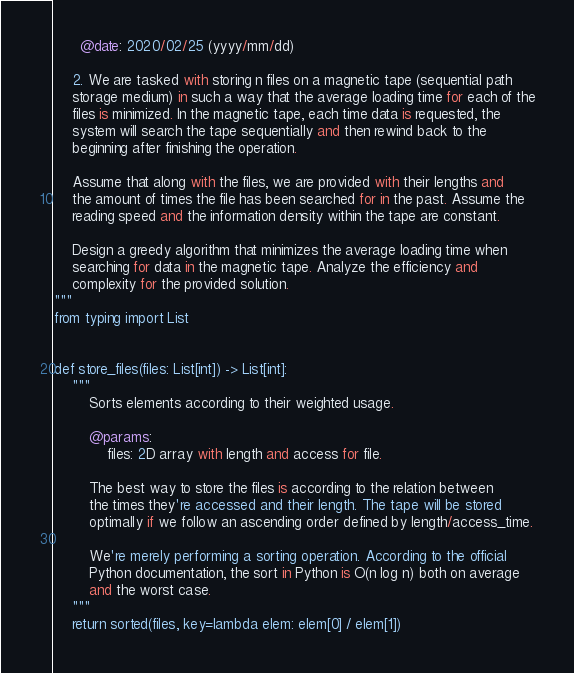Convert code to text. <code><loc_0><loc_0><loc_500><loc_500><_Python_>      @date: 2020/02/25 (yyyy/mm/dd)

    2. We are tasked with storing n files on a magnetic tape (sequential path
    storage medium) in such a way that the average loading time for each of the
    files is minimized. In the magnetic tape, each time data is requested, the
    system will search the tape sequentially and then rewind back to the
    beginning after finishing the operation.

    Assume that along with the files, we are provided with their lengths and
    the amount of times the file has been searched for in the past. Assume the
    reading speed and the information density within the tape are constant.

    Design a greedy algorithm that minimizes the average loading time when
    searching for data in the magnetic tape. Analyze the efficiency and
    complexity for the provided solution.
"""
from typing import List


def store_files(files: List[int]) -> List[int]:
    """
        Sorts elements according to their weighted usage.

        @params:
            files: 2D array with length and access for file.

        The best way to store the files is according to the relation between
        the times they're accessed and their length. The tape will be stored
        optimally if we follow an ascending order defined by length/access_time.

        We're merely performing a sorting operation. According to the official
        Python documentation, the sort in Python is O(n log n) both on average
        and the worst case.
    """
    return sorted(files, key=lambda elem: elem[0] / elem[1])
</code> 